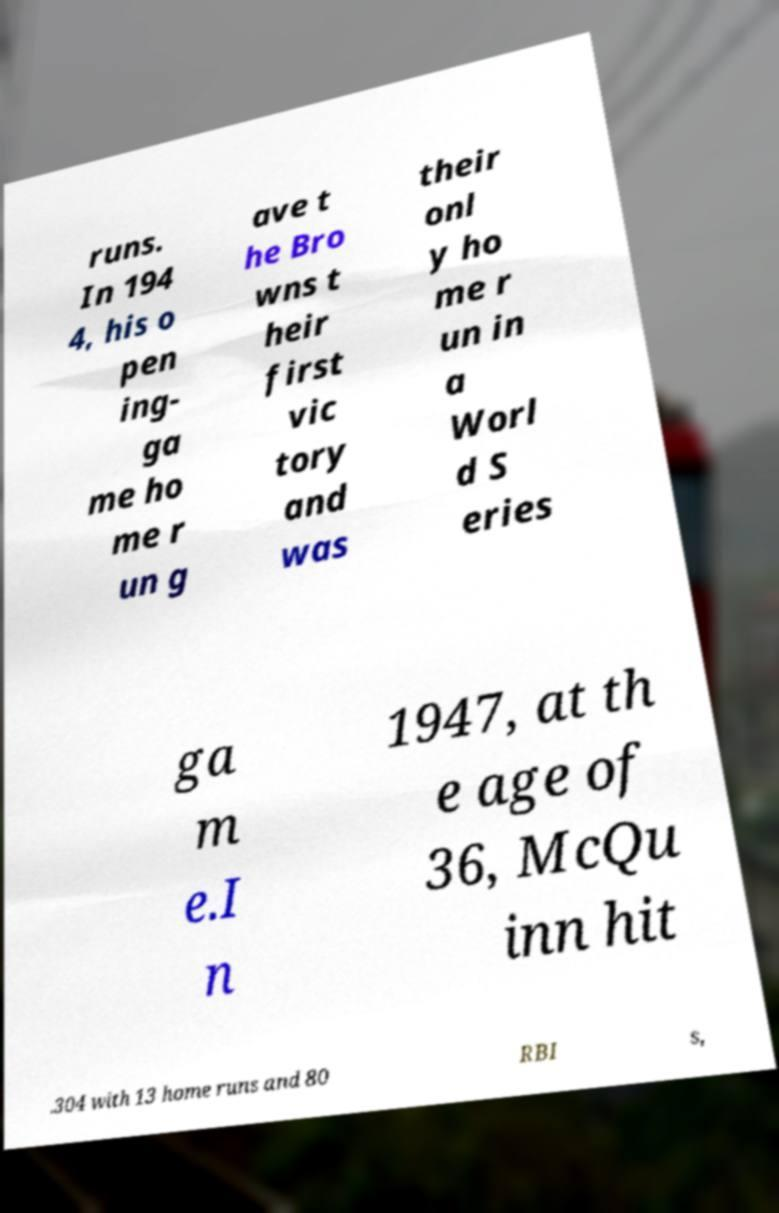Please read and relay the text visible in this image. What does it say? runs. In 194 4, his o pen ing- ga me ho me r un g ave t he Bro wns t heir first vic tory and was their onl y ho me r un in a Worl d S eries ga m e.I n 1947, at th e age of 36, McQu inn hit .304 with 13 home runs and 80 RBI s, 